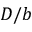Convert formula to latex. <formula><loc_0><loc_0><loc_500><loc_500>D / b</formula> 